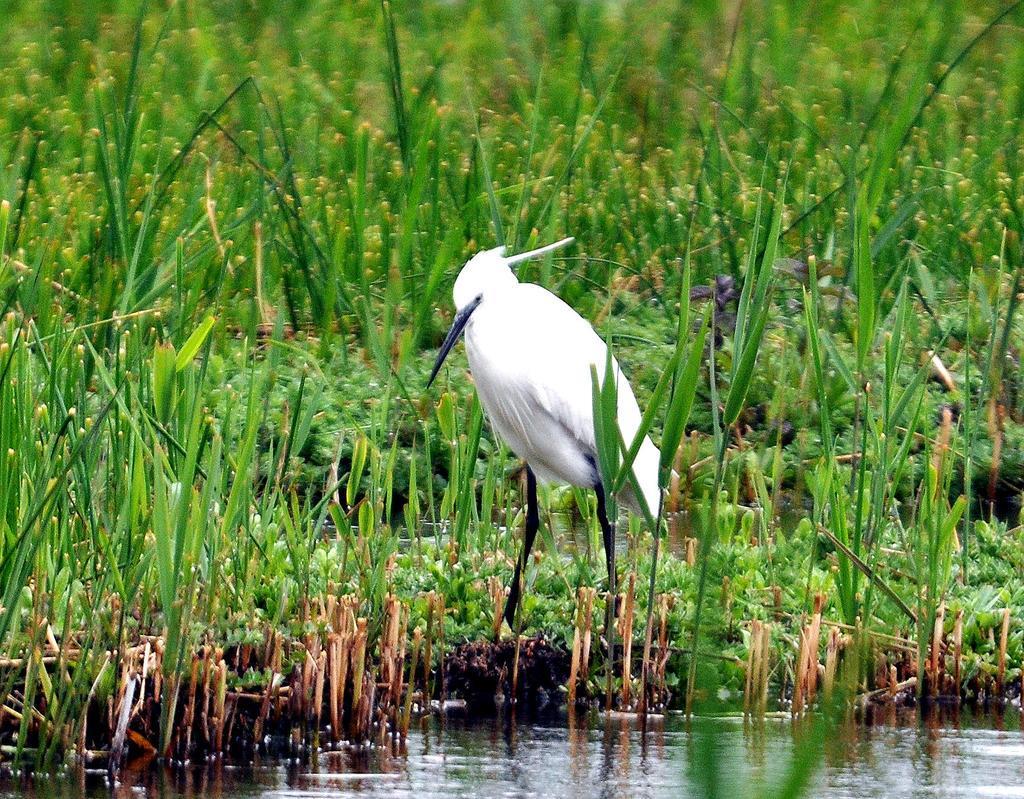Could you give a brief overview of what you see in this image? In the center of the image we can see a bird and there is grass. At the bottom there is water. 